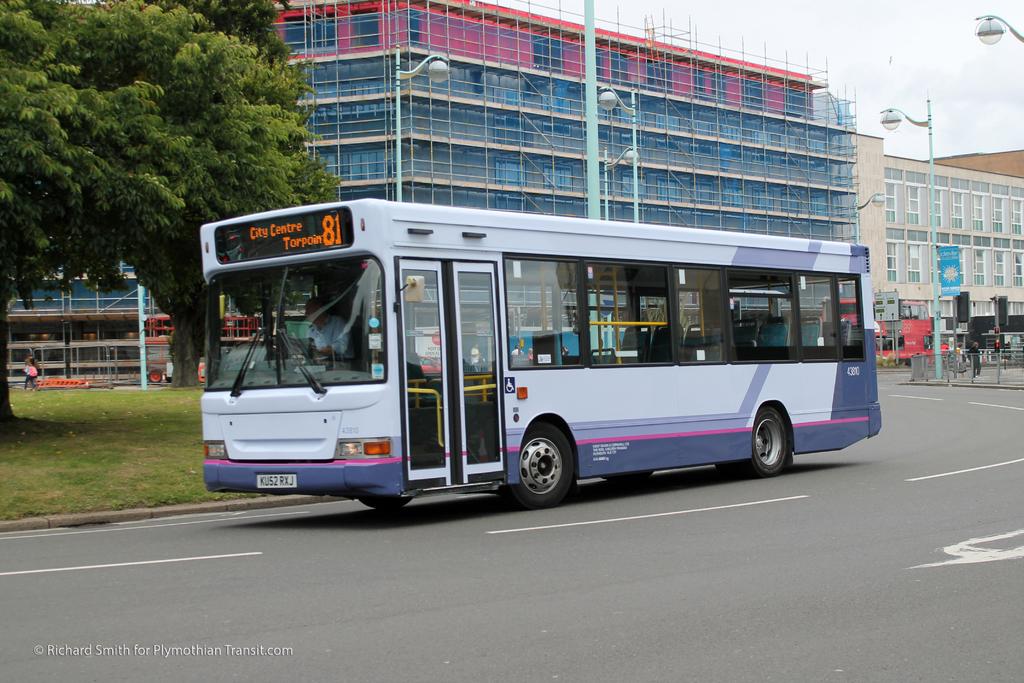Where is the bus headed?
Your response must be concise. City centre. What number bus is this?
Provide a succinct answer. 81. 